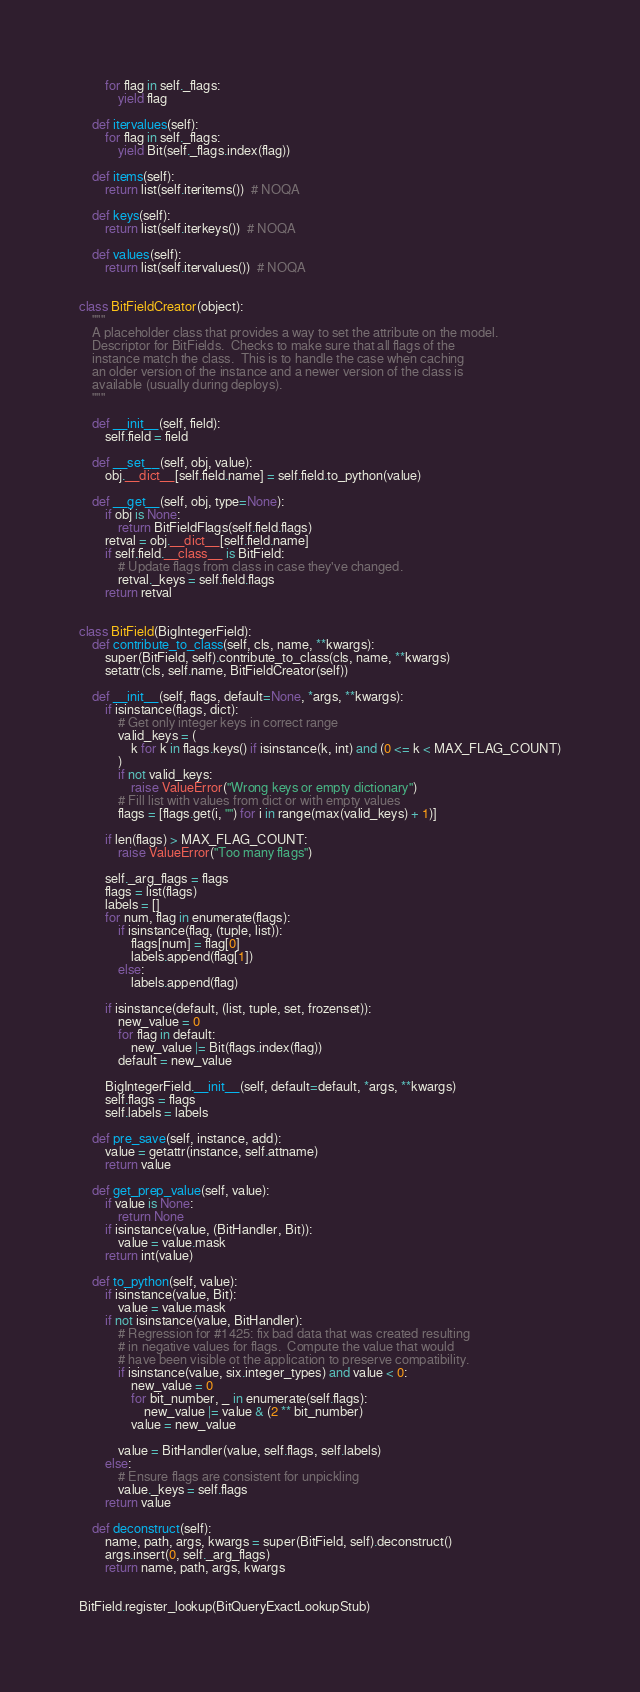Convert code to text. <code><loc_0><loc_0><loc_500><loc_500><_Python_>        for flag in self._flags:
            yield flag

    def itervalues(self):
        for flag in self._flags:
            yield Bit(self._flags.index(flag))

    def items(self):
        return list(self.iteritems())  # NOQA

    def keys(self):
        return list(self.iterkeys())  # NOQA

    def values(self):
        return list(self.itervalues())  # NOQA


class BitFieldCreator(object):
    """
    A placeholder class that provides a way to set the attribute on the model.
    Descriptor for BitFields.  Checks to make sure that all flags of the
    instance match the class.  This is to handle the case when caching
    an older version of the instance and a newer version of the class is
    available (usually during deploys).
    """

    def __init__(self, field):
        self.field = field

    def __set__(self, obj, value):
        obj.__dict__[self.field.name] = self.field.to_python(value)

    def __get__(self, obj, type=None):
        if obj is None:
            return BitFieldFlags(self.field.flags)
        retval = obj.__dict__[self.field.name]
        if self.field.__class__ is BitField:
            # Update flags from class in case they've changed.
            retval._keys = self.field.flags
        return retval


class BitField(BigIntegerField):
    def contribute_to_class(self, cls, name, **kwargs):
        super(BitField, self).contribute_to_class(cls, name, **kwargs)
        setattr(cls, self.name, BitFieldCreator(self))

    def __init__(self, flags, default=None, *args, **kwargs):
        if isinstance(flags, dict):
            # Get only integer keys in correct range
            valid_keys = (
                k for k in flags.keys() if isinstance(k, int) and (0 <= k < MAX_FLAG_COUNT)
            )
            if not valid_keys:
                raise ValueError("Wrong keys or empty dictionary")
            # Fill list with values from dict or with empty values
            flags = [flags.get(i, "") for i in range(max(valid_keys) + 1)]

        if len(flags) > MAX_FLAG_COUNT:
            raise ValueError("Too many flags")

        self._arg_flags = flags
        flags = list(flags)
        labels = []
        for num, flag in enumerate(flags):
            if isinstance(flag, (tuple, list)):
                flags[num] = flag[0]
                labels.append(flag[1])
            else:
                labels.append(flag)

        if isinstance(default, (list, tuple, set, frozenset)):
            new_value = 0
            for flag in default:
                new_value |= Bit(flags.index(flag))
            default = new_value

        BigIntegerField.__init__(self, default=default, *args, **kwargs)
        self.flags = flags
        self.labels = labels

    def pre_save(self, instance, add):
        value = getattr(instance, self.attname)
        return value

    def get_prep_value(self, value):
        if value is None:
            return None
        if isinstance(value, (BitHandler, Bit)):
            value = value.mask
        return int(value)

    def to_python(self, value):
        if isinstance(value, Bit):
            value = value.mask
        if not isinstance(value, BitHandler):
            # Regression for #1425: fix bad data that was created resulting
            # in negative values for flags.  Compute the value that would
            # have been visible ot the application to preserve compatibility.
            if isinstance(value, six.integer_types) and value < 0:
                new_value = 0
                for bit_number, _ in enumerate(self.flags):
                    new_value |= value & (2 ** bit_number)
                value = new_value

            value = BitHandler(value, self.flags, self.labels)
        else:
            # Ensure flags are consistent for unpickling
            value._keys = self.flags
        return value

    def deconstruct(self):
        name, path, args, kwargs = super(BitField, self).deconstruct()
        args.insert(0, self._arg_flags)
        return name, path, args, kwargs


BitField.register_lookup(BitQueryExactLookupStub)
</code> 